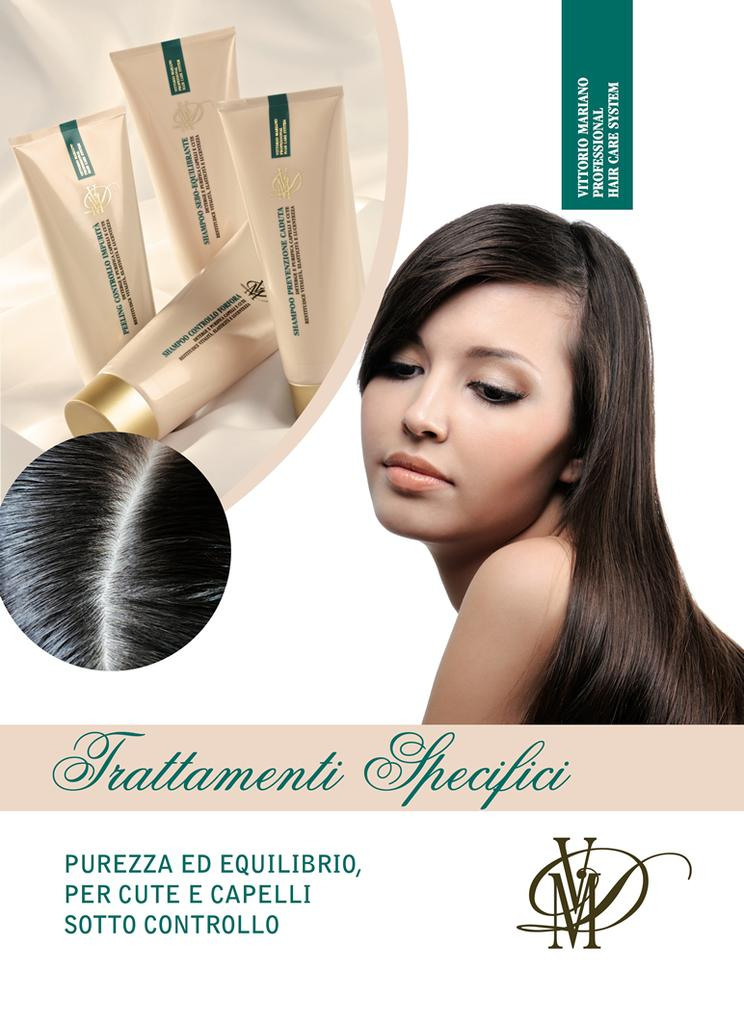<image>
Share a concise interpretation of the image provided. An advertisement for a hair care product says "Frattamenti Specifici." 